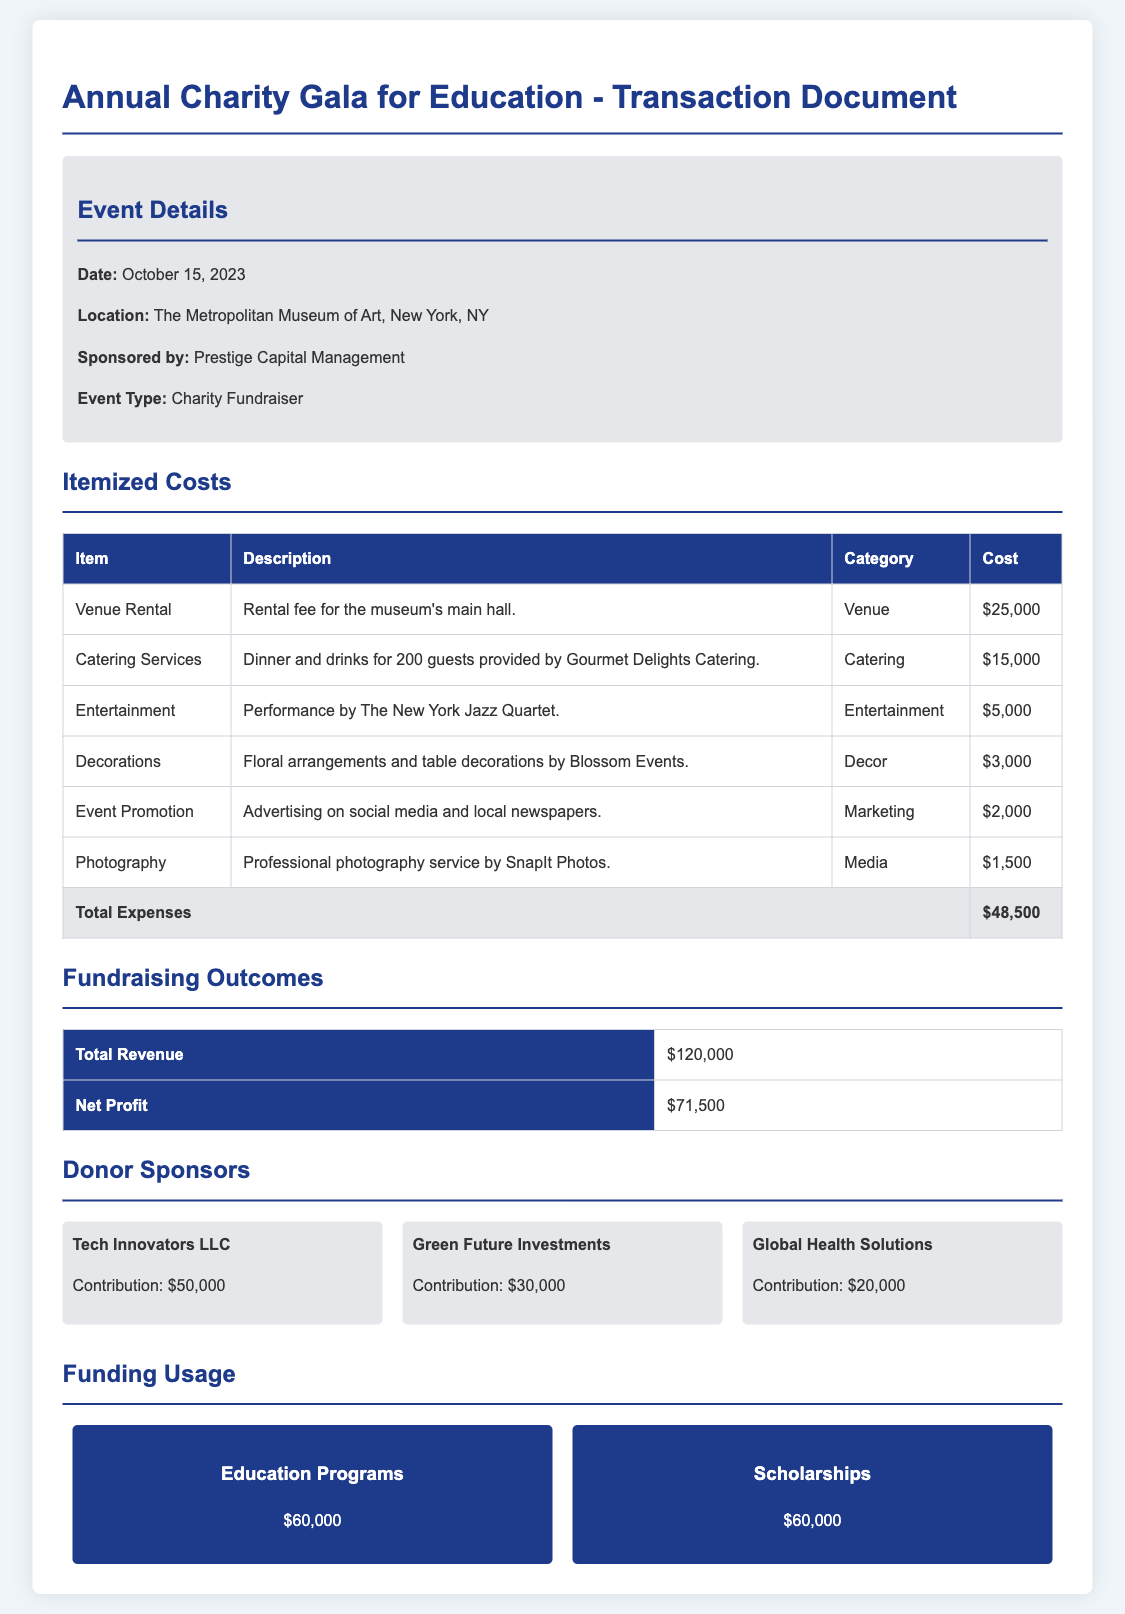What is the date of the event? The date of the event is stated in the event details section of the document.
Answer: October 15, 2023 What is the total cost for catering services? The cost for catering services is specifically mentioned in the itemized costs table.
Answer: $15,000 Who provided the photography services? The organization that provided the photography service can be found in the itemized costs section.
Answer: SnapIt Photos What was the total revenue from the event? The total revenue is listed under the fundraising outcomes section of the document.
Answer: $120,000 What is the net profit from the event? The net profit can be found in the fundraising outcomes table and is calculated as total revenue minus total expenses.
Answer: $71,500 How much did Tech Innovators LLC contribute? The contribution from this sponsor is mentioned in the donor sponsors section.
Answer: $50,000 What is the total expense amount? The total expenses are calculated and provided in the itemized costs table at the end of that section.
Answer: $48,500 How much funding is allocated to education programs? The funding for education programs is specified in the funding usage section of the document.
Answer: $60,000 What type of event is this document about? The type of event is described in the event details section of the document.
Answer: Charity Fundraiser 